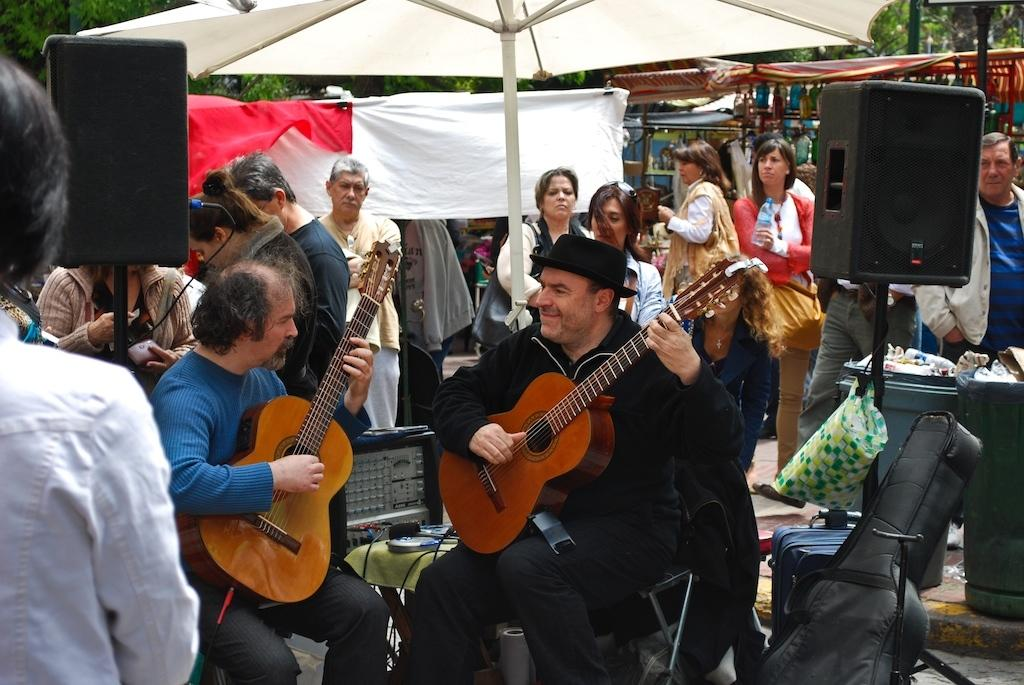What is the main subject of the image? The main subject of the image is a group of people. Where are the people located in the image? The people are standing under a tent. What are two people in the group doing? Two people in the group are sitting and playing a guitar. What type of plastic material can be seen in the image? There is no plastic material present in the image. What are the people in the image writing on? The image does not show any writing or writing materials. 